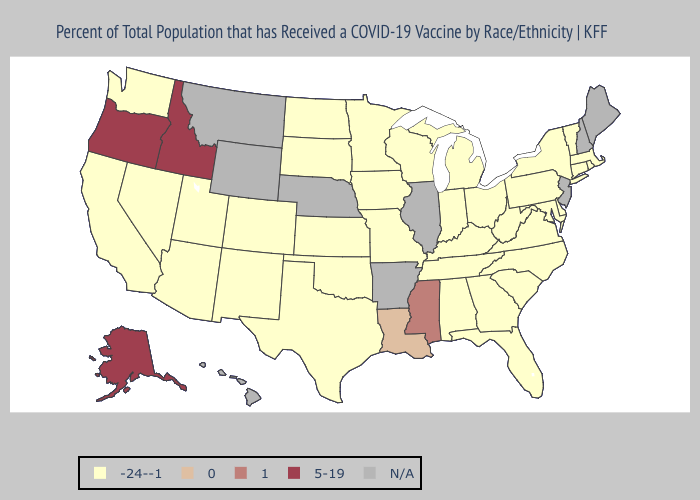What is the lowest value in the South?
Short answer required. -24--1. Which states have the lowest value in the South?
Give a very brief answer. Alabama, Delaware, Florida, Georgia, Kentucky, Maryland, North Carolina, Oklahoma, South Carolina, Tennessee, Texas, Virginia, West Virginia. Among the states that border Arkansas , does Mississippi have the highest value?
Answer briefly. Yes. How many symbols are there in the legend?
Keep it brief. 5. Is the legend a continuous bar?
Keep it brief. No. What is the value of Maryland?
Quick response, please. -24--1. What is the lowest value in the MidWest?
Quick response, please. -24--1. Name the states that have a value in the range 5-19?
Answer briefly. Alaska, Idaho, Oregon. Does Alaska have the lowest value in the USA?
Be succinct. No. Name the states that have a value in the range -24--1?
Write a very short answer. Alabama, Arizona, California, Colorado, Connecticut, Delaware, Florida, Georgia, Indiana, Iowa, Kansas, Kentucky, Maryland, Massachusetts, Michigan, Minnesota, Missouri, Nevada, New Mexico, New York, North Carolina, North Dakota, Ohio, Oklahoma, Pennsylvania, Rhode Island, South Carolina, South Dakota, Tennessee, Texas, Utah, Vermont, Virginia, Washington, West Virginia, Wisconsin. What is the value of Kansas?
Write a very short answer. -24--1. What is the lowest value in states that border Indiana?
Write a very short answer. -24--1. 